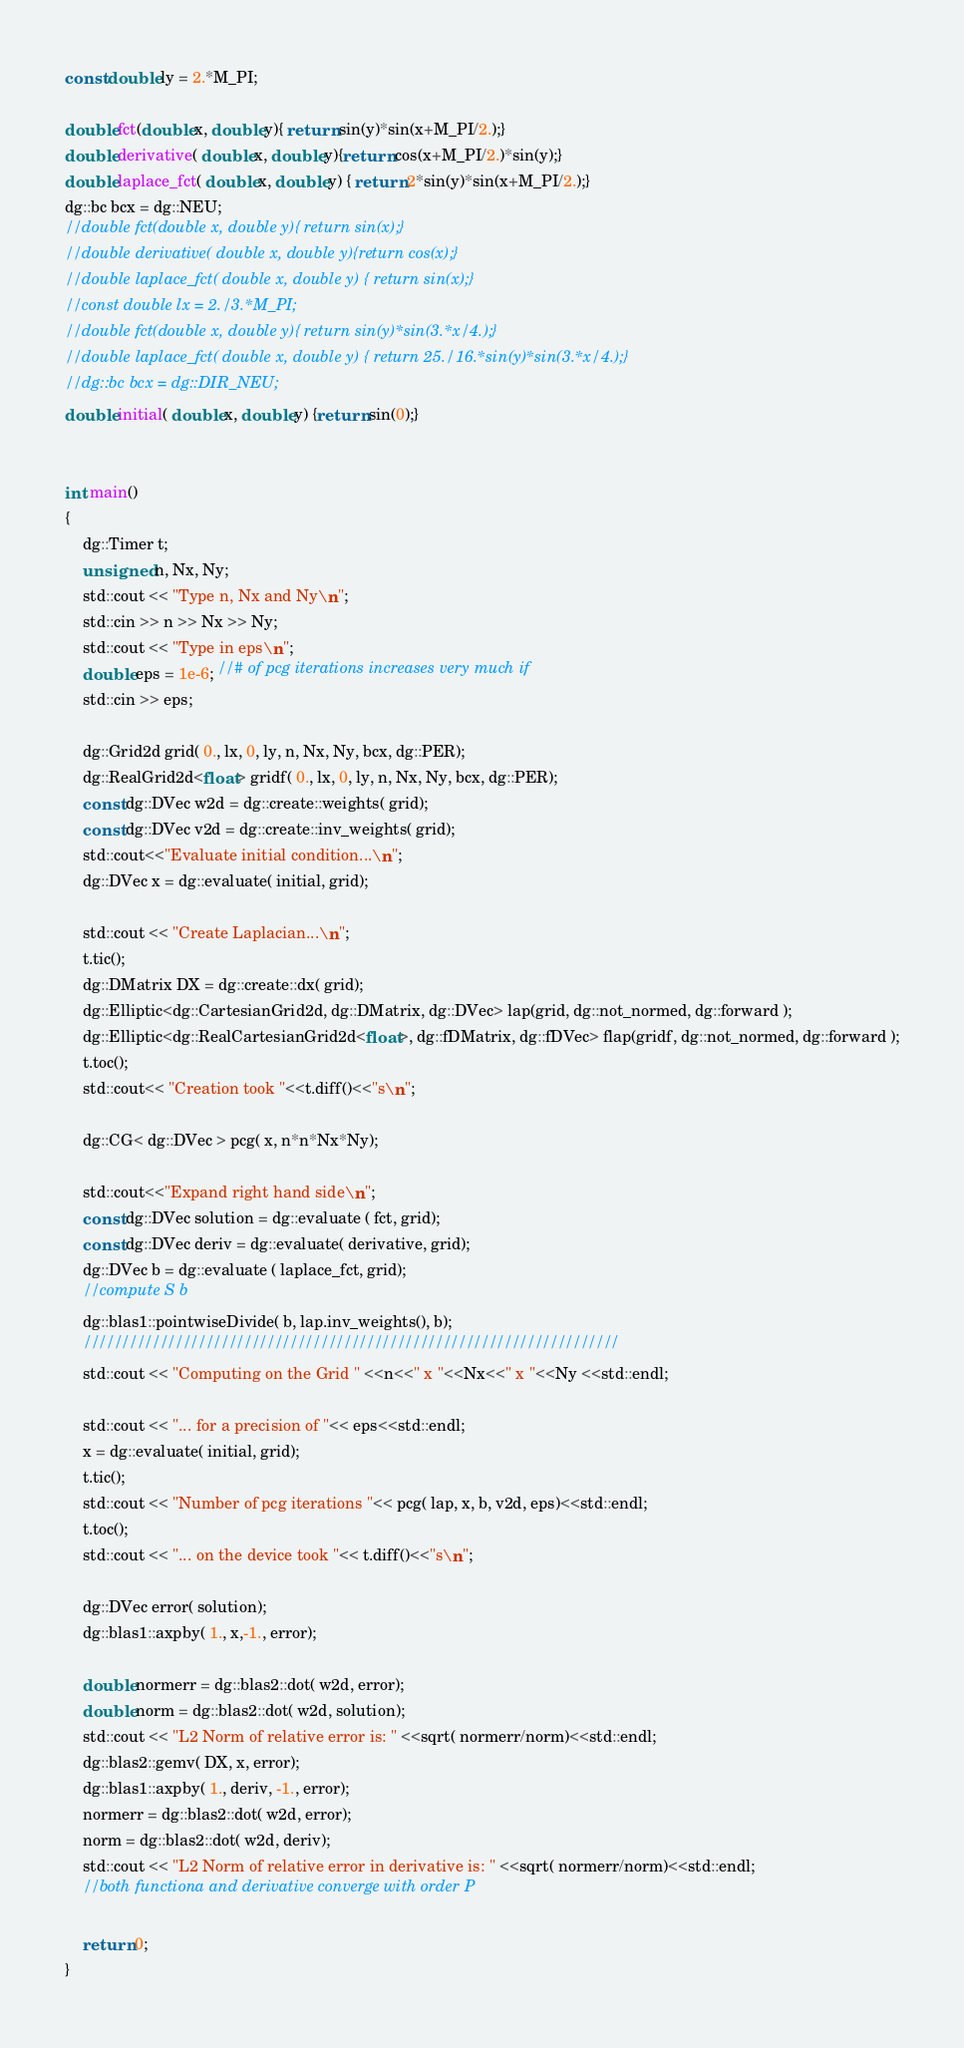<code> <loc_0><loc_0><loc_500><loc_500><_Cuda_>const double ly = 2.*M_PI;

double fct(double x, double y){ return sin(y)*sin(x+M_PI/2.);}
double derivative( double x, double y){return cos(x+M_PI/2.)*sin(y);}
double laplace_fct( double x, double y) { return 2*sin(y)*sin(x+M_PI/2.);}
dg::bc bcx = dg::NEU;
//double fct(double x, double y){ return sin(x);}
//double derivative( double x, double y){return cos(x);}
//double laplace_fct( double x, double y) { return sin(x);}
//const double lx = 2./3.*M_PI;
//double fct(double x, double y){ return sin(y)*sin(3.*x/4.);}
//double laplace_fct( double x, double y) { return 25./16.*sin(y)*sin(3.*x/4.);}
//dg::bc bcx = dg::DIR_NEU;
double initial( double x, double y) {return sin(0);}


int main()
{
    dg::Timer t;
    unsigned n, Nx, Ny;
    std::cout << "Type n, Nx and Ny\n";
    std::cin >> n >> Nx >> Ny;
    std::cout << "Type in eps\n";
    double eps = 1e-6; //# of pcg iterations increases very much if
    std::cin >> eps;

    dg::Grid2d grid( 0., lx, 0, ly, n, Nx, Ny, bcx, dg::PER);
    dg::RealGrid2d<float> gridf( 0., lx, 0, ly, n, Nx, Ny, bcx, dg::PER);
    const dg::DVec w2d = dg::create::weights( grid);
    const dg::DVec v2d = dg::create::inv_weights( grid);
    std::cout<<"Evaluate initial condition...\n";
    dg::DVec x = dg::evaluate( initial, grid);

    std::cout << "Create Laplacian...\n";
    t.tic();
    dg::DMatrix DX = dg::create::dx( grid);
    dg::Elliptic<dg::CartesianGrid2d, dg::DMatrix, dg::DVec> lap(grid, dg::not_normed, dg::forward );
    dg::Elliptic<dg::RealCartesianGrid2d<float>, dg::fDMatrix, dg::fDVec> flap(gridf, dg::not_normed, dg::forward );
    t.toc();
    std::cout<< "Creation took "<<t.diff()<<"s\n";

    dg::CG< dg::DVec > pcg( x, n*n*Nx*Ny);

    std::cout<<"Expand right hand side\n";
    const dg::DVec solution = dg::evaluate ( fct, grid);
    const dg::DVec deriv = dg::evaluate( derivative, grid);
    dg::DVec b = dg::evaluate ( laplace_fct, grid);
    //compute S b
    dg::blas1::pointwiseDivide( b, lap.inv_weights(), b);
    //////////////////////////////////////////////////////////////////////
    std::cout << "Computing on the Grid " <<n<<" x "<<Nx<<" x "<<Ny <<std::endl;

    std::cout << "... for a precision of "<< eps<<std::endl;
    x = dg::evaluate( initial, grid);
    t.tic();
    std::cout << "Number of pcg iterations "<< pcg( lap, x, b, v2d, eps)<<std::endl;
    t.toc();
    std::cout << "... on the device took "<< t.diff()<<"s\n";

    dg::DVec error( solution);
    dg::blas1::axpby( 1., x,-1., error);

    double normerr = dg::blas2::dot( w2d, error);
    double norm = dg::blas2::dot( w2d, solution);
    std::cout << "L2 Norm of relative error is: " <<sqrt( normerr/norm)<<std::endl;
    dg::blas2::gemv( DX, x, error);
    dg::blas1::axpby( 1., deriv, -1., error);
    normerr = dg::blas2::dot( w2d, error);
    norm = dg::blas2::dot( w2d, deriv);
    std::cout << "L2 Norm of relative error in derivative is: " <<sqrt( normerr/norm)<<std::endl;
    //both functiona and derivative converge with order P

    return 0;
}
</code> 